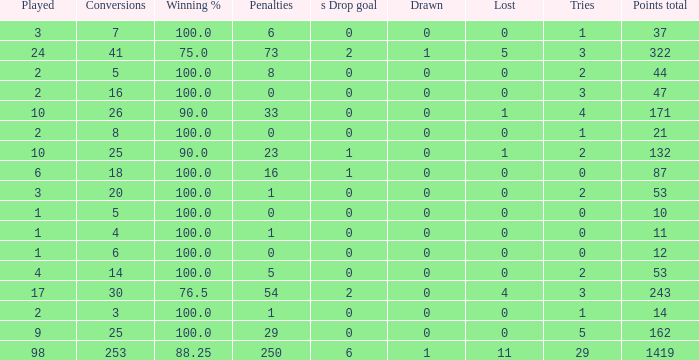What is the least number of penalties he got when his point total was over 1419 in more than 98 games? None. 